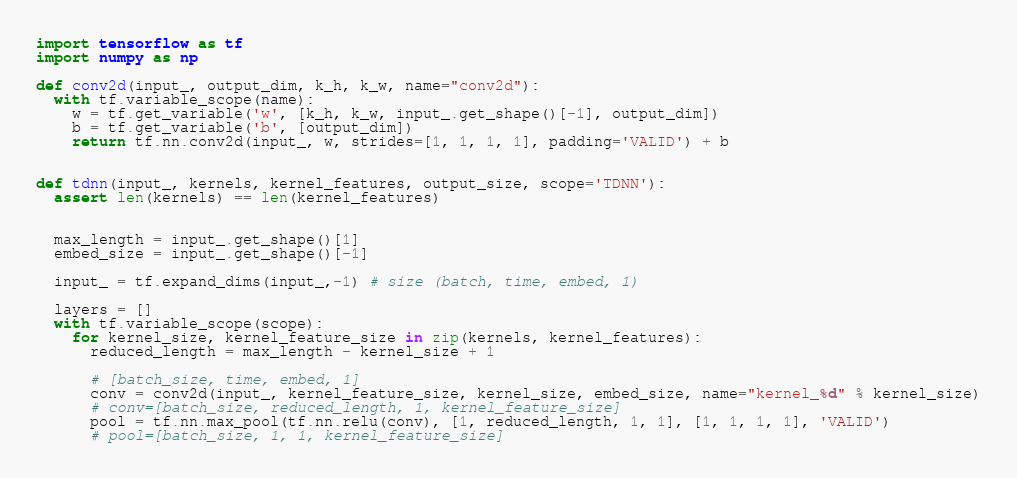Convert code to text. <code><loc_0><loc_0><loc_500><loc_500><_Python_>import tensorflow as tf
import numpy as np

def conv2d(input_, output_dim, k_h, k_w, name="conv2d"):
  with tf.variable_scope(name):
    w = tf.get_variable('w', [k_h, k_w, input_.get_shape()[-1], output_dim])
    b = tf.get_variable('b', [output_dim])
    return tf.nn.conv2d(input_, w, strides=[1, 1, 1, 1], padding='VALID') + b


def tdnn(input_, kernels, kernel_features, output_size, scope='TDNN'):
  assert len(kernels) == len(kernel_features)


  max_length = input_.get_shape()[1]
  embed_size = input_.get_shape()[-1]

  input_ = tf.expand_dims(input_,-1) # size (batch, time, embed, 1)

  layers = []
  with tf.variable_scope(scope):
    for kernel_size, kernel_feature_size in zip(kernels, kernel_features):
      reduced_length = max_length - kernel_size + 1

      # [batch_size, time, embed, 1]
      conv = conv2d(input_, kernel_feature_size, kernel_size, embed_size, name="kernel_%d" % kernel_size)
      # conv=[batch_size, reduced_length, 1, kernel_feature_size]
      pool = tf.nn.max_pool(tf.nn.relu(conv), [1, reduced_length, 1, 1], [1, 1, 1, 1], 'VALID')
      # pool=[batch_size, 1, 1, kernel_feature_size]</code> 